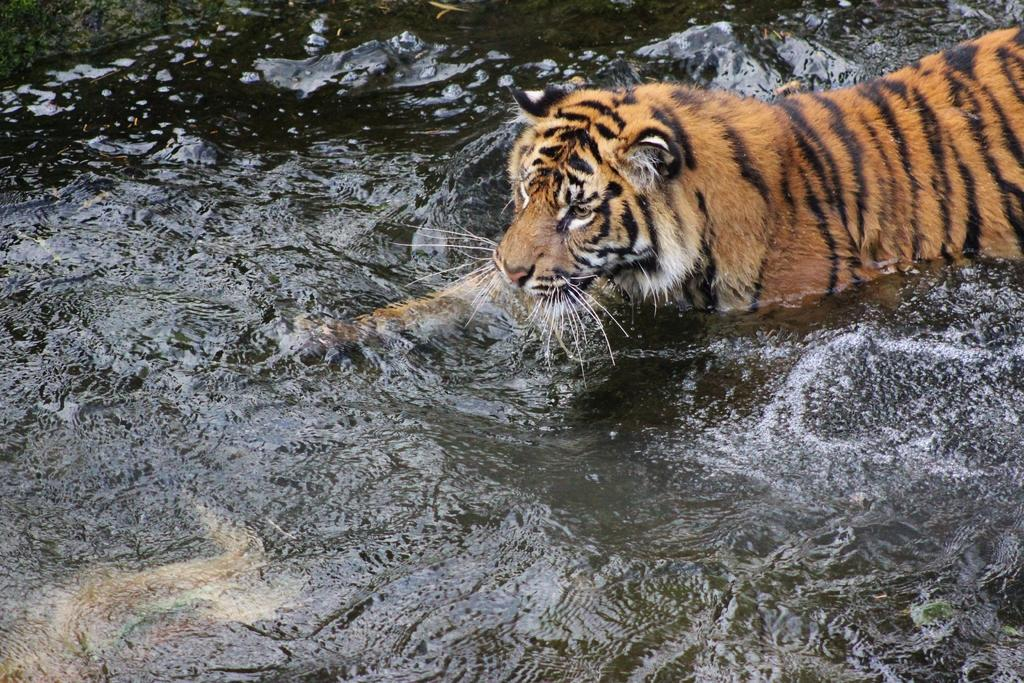What animal is in the image? There is a tiger in the image. Where is the tiger located in the image? The tiger is in the water. What type of spy equipment can be seen in the image? There is no spy equipment present in the image; it features a tiger in the water. What is the tiger's brother doing in the image? There is no mention of a brother or any other tiger in the image, only one tiger is present. 